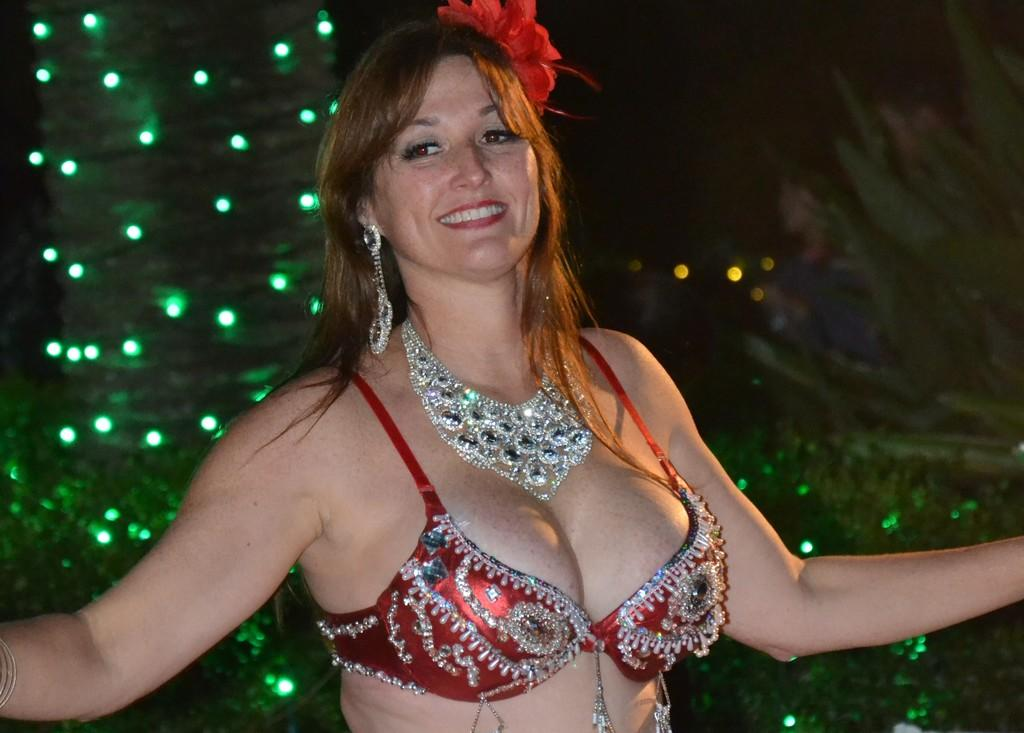Who is present in the image? There is a woman in the image. What is the woman doing in the image? The woman is standing and smiling. What can be seen in the background of the image? Trees and lights are visible in the background of the image. What sense does the woman use to taste the lip in the image? There is no lip present in the image, and therefore no tasting or use of senses related to it. 